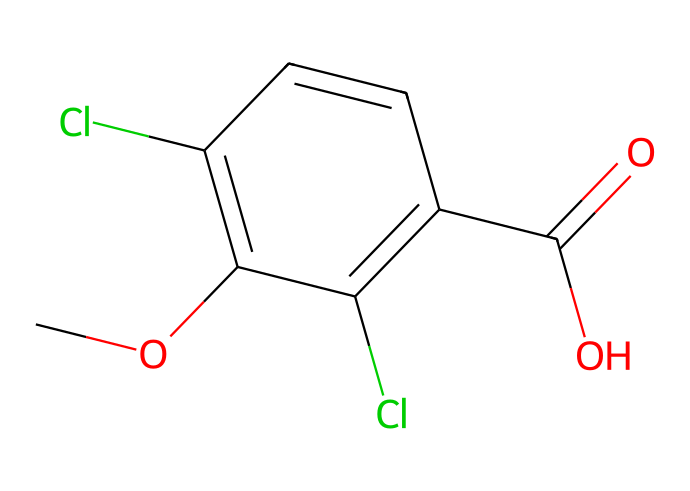What is the molecular formula of dicamba? To determine the molecular formula, count the types and number of atoms present in the SMILES representation: 3 Carbon (C) from the aromatic ring + 1 from the methoxy group + 1 from the carboxylic acid group gives a total of 5 Carbons (C); the hydrogens and oxygens can also be counted from the structure: 5 Hydrogens (H) and 2 Oxygens (O). Thus, the molecular formula is C8H8Cl2O3.
Answer: C8H8Cl2O3 How many chlorine atoms are present in dicamba? In the SMILES representation, "Cl" indicates the presence of chlorine atoms. By counting the occurrences of "Cl" in the chemical, there are 2 chlorine atoms in the structure.
Answer: 2 What functional groups are present in dicamba? The SMILES representation shows "C(=O)O" for the carboxylic acid group and "O" for the methoxy group. Additionally, there’s a chlorine atom attached to the benzene ring. Hence, the two functional groups present are methoxy (-OCH3) and carboxylic acid (-COOH).
Answer: methoxy and carboxylic acid What type of herbicide is dicamba considered? Dicamba belongs to the class of synthetic auxins, a type of herbicide that mimics natural plant hormones to control broadleaf weeds. Its structure, especially the presence of the aromatic rings, supports its classification.
Answer: synthetic auxin What is the significance of the chlorinated aromatic structure in dicamba? The chlorinated aromatic structure contributes to the herbicide's efficacy and stability. Chlorine atoms enhance the herbicide's ability to resist degradation and increase its antagonist action on target weeds. This allows dicamba to remain active in the environment longer than non-chlorinated compounds.
Answer: efficacy and stability Explain how the molecular structure of dicamba influences its action as a herbicide. The arrangement of the aromatic rings, including the presence of the methoxy group and the carboxylic acid, provides specific chemical interactions with plant hormone receptors. The similarity to indole-3-acetic acid (a natural auxin) allows dicamba to induce uncontrolled growth in susceptible plants, effectively killing broadleaf weeds. The comprehensive structure including functional groups is crucial for its herbicidal activity.
Answer: herbicidal activity 